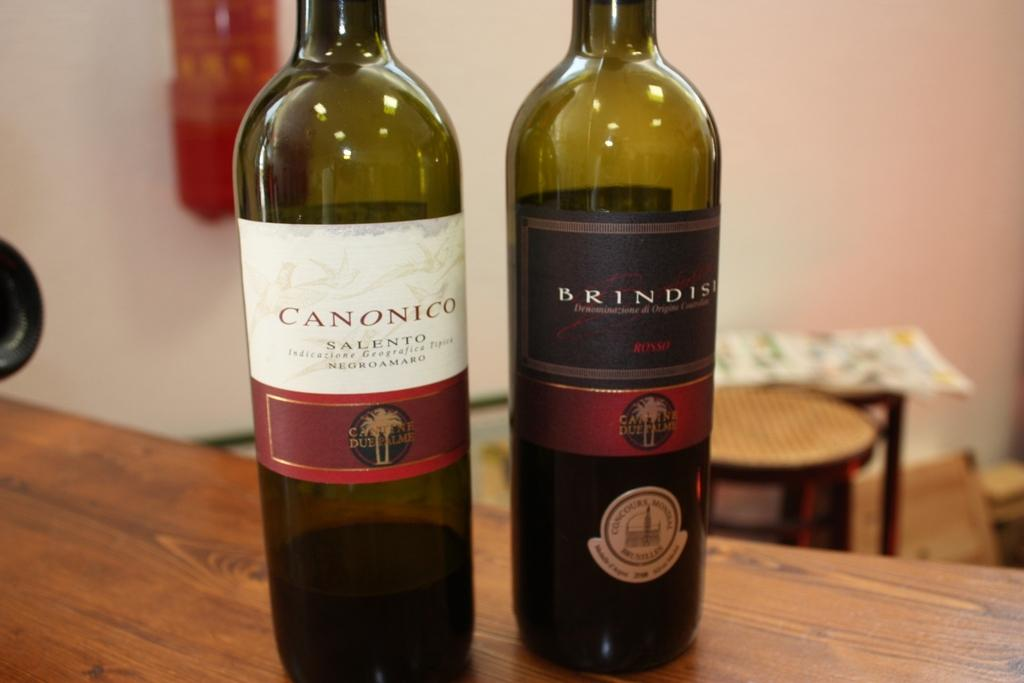How many wine bottles are visible in the image? There are two wine bottles in the image. Where are the wine bottles located? The wine bottles are on a table. What type of agreement was reached between the wine bottles in the image? There is no indication of any agreement between the wine bottles in the image, as they are inanimate objects. 